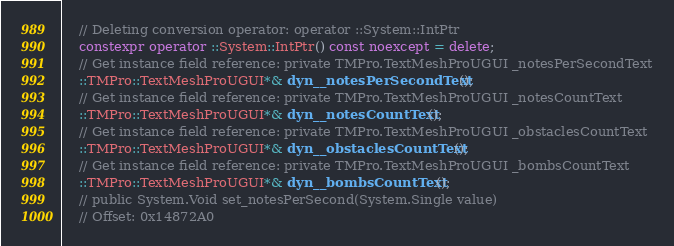Convert code to text. <code><loc_0><loc_0><loc_500><loc_500><_C++_>    // Deleting conversion operator: operator ::System::IntPtr
    constexpr operator ::System::IntPtr() const noexcept = delete;
    // Get instance field reference: private TMPro.TextMeshProUGUI _notesPerSecondText
    ::TMPro::TextMeshProUGUI*& dyn__notesPerSecondText();
    // Get instance field reference: private TMPro.TextMeshProUGUI _notesCountText
    ::TMPro::TextMeshProUGUI*& dyn__notesCountText();
    // Get instance field reference: private TMPro.TextMeshProUGUI _obstaclesCountText
    ::TMPro::TextMeshProUGUI*& dyn__obstaclesCountText();
    // Get instance field reference: private TMPro.TextMeshProUGUI _bombsCountText
    ::TMPro::TextMeshProUGUI*& dyn__bombsCountText();
    // public System.Void set_notesPerSecond(System.Single value)
    // Offset: 0x14872A0</code> 